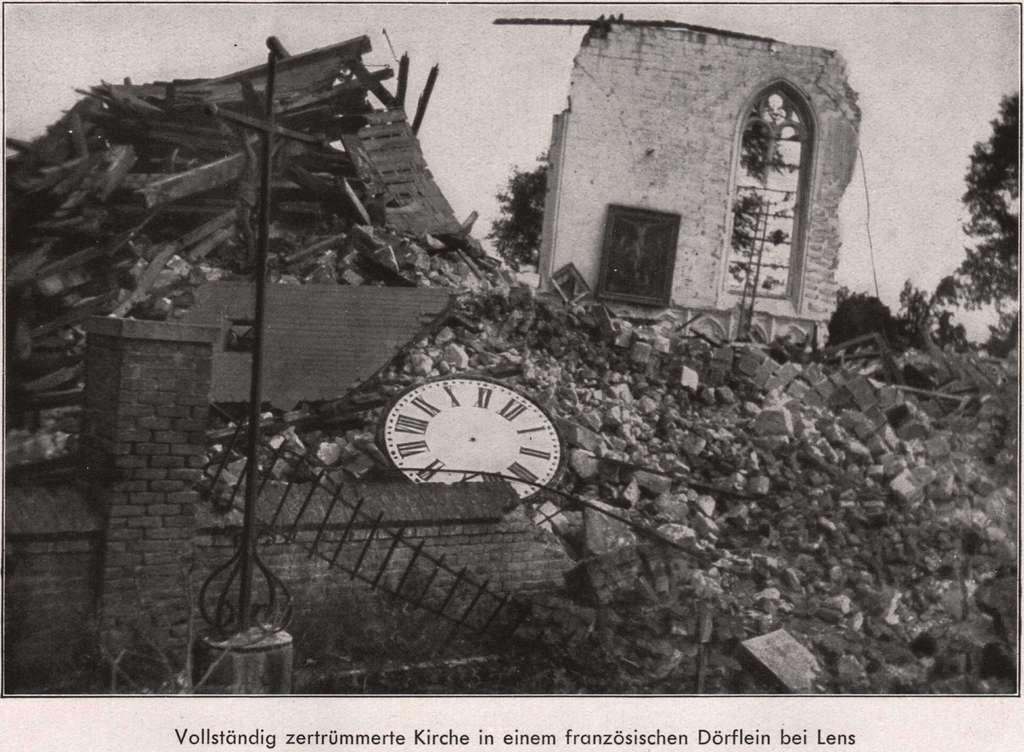<image>
Render a clear and concise summary of the photo. a clock lays near a pile of rubble with a caption that says Vollstandig 